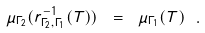Convert formula to latex. <formula><loc_0><loc_0><loc_500><loc_500>\mu _ { \Gamma _ { 2 } } ( r _ { \Gamma _ { 2 } , \Gamma _ { 1 } } ^ { - 1 } ( T ) ) \ = \ \mu _ { \Gamma _ { 1 } } ( T ) \ .</formula> 